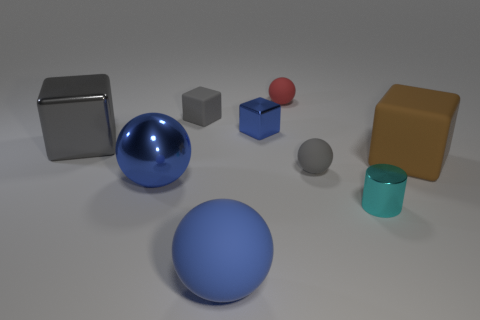Do the large metal cube and the matte cube that is on the left side of the small metallic cylinder have the same color?
Your response must be concise. Yes. There is a blue object that is the same shape as the gray shiny thing; what is it made of?
Provide a succinct answer. Metal. Is there any other thing that is the same color as the big metal block?
Provide a succinct answer. Yes. There is a block right of the gray ball; does it have the same size as the metallic object that is behind the gray metallic cube?
Your response must be concise. No. What number of objects are gray cubes to the left of the tiny gray block or tiny purple shiny blocks?
Provide a succinct answer. 1. There is a large cube to the left of the big brown object; what is it made of?
Offer a very short reply. Metal. What material is the gray sphere?
Your answer should be very brief. Rubber. What material is the tiny ball that is left of the gray rubber thing that is on the right side of the blue metallic object behind the big gray shiny block made of?
Provide a succinct answer. Rubber. Is the size of the blue metallic sphere the same as the rubber cube that is on the right side of the tiny matte cube?
Your answer should be very brief. Yes. How many things are cubes to the left of the red matte ball or small metal objects left of the small cylinder?
Ensure brevity in your answer.  3. 